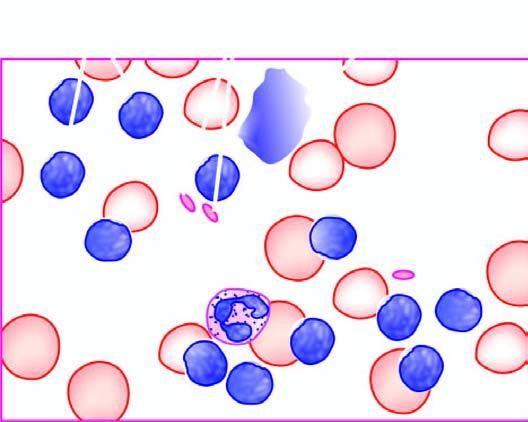what is degenerated forms appearing as bare smudged nuclei?
Answer the question using a single word or phrase. Some excess of mature and small differentiated lymphocytes 